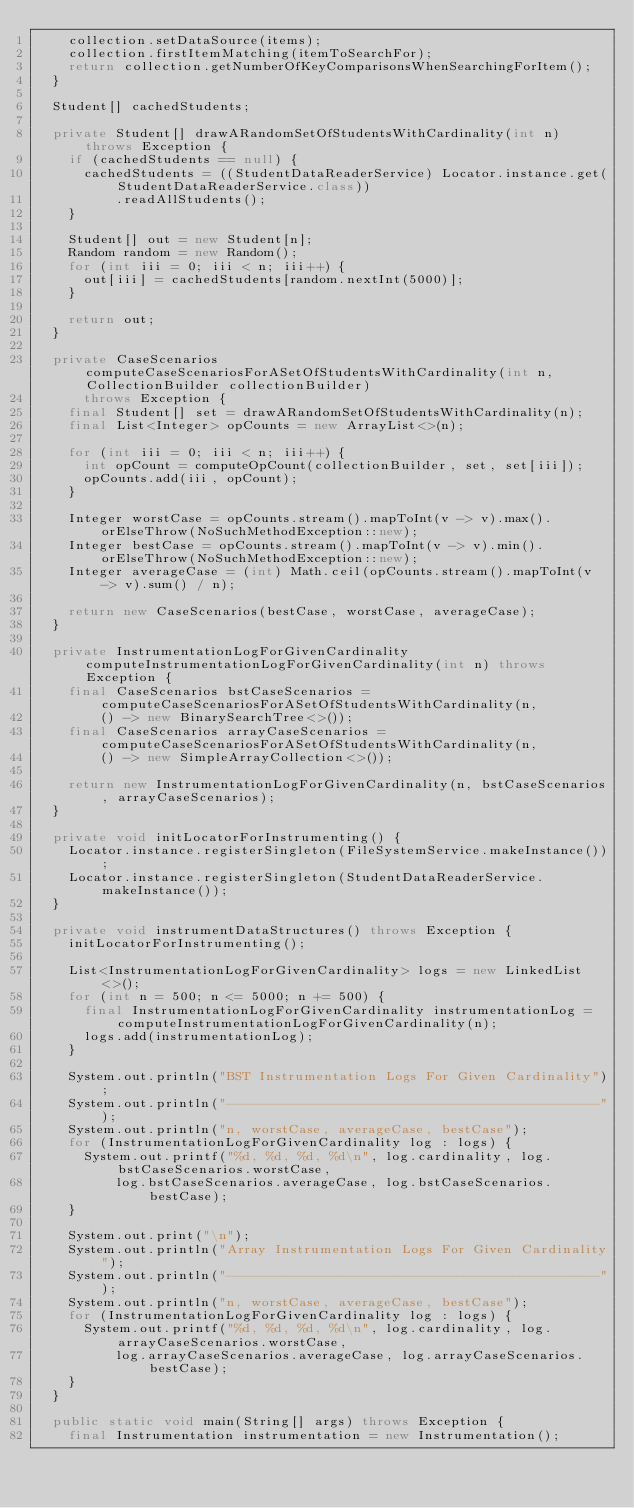Convert code to text. <code><loc_0><loc_0><loc_500><loc_500><_Java_>    collection.setDataSource(items);
    collection.firstItemMatching(itemToSearchFor);
    return collection.getNumberOfKeyComparisonsWhenSearchingForItem();
  }

  Student[] cachedStudents;

  private Student[] drawARandomSetOfStudentsWithCardinality(int n) throws Exception {
    if (cachedStudents == null) {
      cachedStudents = ((StudentDataReaderService) Locator.instance.get(StudentDataReaderService.class))
          .readAllStudents();
    }

    Student[] out = new Student[n];
    Random random = new Random();
    for (int iii = 0; iii < n; iii++) {
      out[iii] = cachedStudents[random.nextInt(5000)];
    }

    return out;
  }

  private CaseScenarios computeCaseScenariosForASetOfStudentsWithCardinality(int n, CollectionBuilder collectionBuilder)
      throws Exception {
    final Student[] set = drawARandomSetOfStudentsWithCardinality(n);
    final List<Integer> opCounts = new ArrayList<>(n);

    for (int iii = 0; iii < n; iii++) {
      int opCount = computeOpCount(collectionBuilder, set, set[iii]);
      opCounts.add(iii, opCount);
    }

    Integer worstCase = opCounts.stream().mapToInt(v -> v).max().orElseThrow(NoSuchMethodException::new);
    Integer bestCase = opCounts.stream().mapToInt(v -> v).min().orElseThrow(NoSuchMethodException::new);
    Integer averageCase = (int) Math.ceil(opCounts.stream().mapToInt(v -> v).sum() / n);

    return new CaseScenarios(bestCase, worstCase, averageCase);
  }

  private InstrumentationLogForGivenCardinality computeInstrumentationLogForGivenCardinality(int n) throws Exception {
    final CaseScenarios bstCaseScenarios = computeCaseScenariosForASetOfStudentsWithCardinality(n,
        () -> new BinarySearchTree<>());
    final CaseScenarios arrayCaseScenarios = computeCaseScenariosForASetOfStudentsWithCardinality(n,
        () -> new SimpleArrayCollection<>());

    return new InstrumentationLogForGivenCardinality(n, bstCaseScenarios, arrayCaseScenarios);
  }

  private void initLocatorForInstrumenting() {
    Locator.instance.registerSingleton(FileSystemService.makeInstance());
    Locator.instance.registerSingleton(StudentDataReaderService.makeInstance());
  }

  private void instrumentDataStructures() throws Exception {
    initLocatorForInstrumenting();

    List<InstrumentationLogForGivenCardinality> logs = new LinkedList<>();
    for (int n = 500; n <= 5000; n += 500) {
      final InstrumentationLogForGivenCardinality instrumentationLog = computeInstrumentationLogForGivenCardinality(n);
      logs.add(instrumentationLog);
    }

    System.out.println("BST Instrumentation Logs For Given Cardinality");
    System.out.println("-----------------------------------------------");
    System.out.println("n, worstCase, averageCase, bestCase");
    for (InstrumentationLogForGivenCardinality log : logs) {
      System.out.printf("%d, %d, %d, %d\n", log.cardinality, log.bstCaseScenarios.worstCase,
          log.bstCaseScenarios.averageCase, log.bstCaseScenarios.bestCase);
    }

    System.out.print("\n");
    System.out.println("Array Instrumentation Logs For Given Cardinality");
    System.out.println("-----------------------------------------------");
    System.out.println("n, worstCase, averageCase, bestCase");
    for (InstrumentationLogForGivenCardinality log : logs) {
      System.out.printf("%d, %d, %d, %d\n", log.cardinality, log.arrayCaseScenarios.worstCase,
          log.arrayCaseScenarios.averageCase, log.arrayCaseScenarios.bestCase);
    }
  }

  public static void main(String[] args) throws Exception {
    final Instrumentation instrumentation = new Instrumentation();</code> 